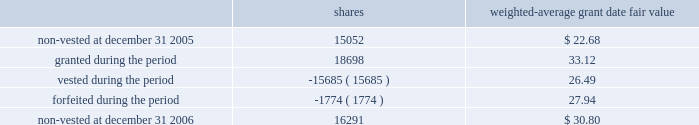O 2019 r e i l l y a u t o m o t i v e 2 0 0 6 a n n u a l r e p o r t p a g e 38 $ 11080000 , in the years ended december 31 , 2006 , 2005 and 2004 , respectively .
The remaining unrecognized compensation cost related to unvested awards at december 31 , 2006 , was $ 7702000 and the weighted-average period of time over which this cost will be recognized is 3.3 years .
Employee stock purchase plan the company 2019s employee stock purchase plan permits all eligible employees to purchase shares of the company 2019s common stock at 85% ( 85 % ) of the fair market value .
Participants may authorize the company to withhold up to 5% ( 5 % ) of their annual salary to participate in the plan .
The stock purchase plan authorizes up to 2600000 shares to be granted .
During the year ended december 31 , 2006 , the company issued 165306 shares under the purchase plan at a weighted average price of $ 27.36 per share .
During the year ended december 31 , 2005 , the company issued 161903 shares under the purchase plan at a weighted average price of $ 27.57 per share .
During the year ended december 31 , 2004 , the company issued 187754 shares under the purchase plan at a weighted average price of $ 20.85 per share .
Sfas no .
123r requires compensation expense to be recognized based on the discount between the grant date fair value and the employee purchase price for shares sold to employees .
During the year ended december 31 , 2006 , the company recorded $ 799000 of compensation cost related to employee share purchases and a corresponding income tax benefit of $ 295000 .
At december 31 , 2006 , approximately 400000 shares were reserved for future issuance .
Other employee benefit plans the company sponsors a contributory profit sharing and savings plan that covers substantially all employees who are at least 21 years of age and have at least six months of service .
The company has agreed to make matching contributions equal to 50% ( 50 % ) of the first 2% ( 2 % ) of each employee 2019s wages that are contributed and 25% ( 25 % ) of the next 4% ( 4 % ) of each employee 2019s wages that are contributed .
The company also makes additional discretionary profit sharing contributions to the plan on an annual basis as determined by the board of directors .
The company 2019s matching and profit sharing contributions under this plan are funded in the form of shares of the company 2019s common stock .
A total of 4200000 shares of common stock have been authorized for issuance under this plan .
During the year ended december 31 , 2006 , the company recorded $ 6429000 of compensation cost for contributions to this plan and a corresponding income tax benefit of $ 2372000 .
During the year ended december 31 , 2005 , the company recorded $ 6606000 of compensation cost for contributions to this plan and a corresponding income tax benefit of $ 2444000 .
During the year ended december 31 , 2004 , the company recorded $ 5278000 of compensation cost for contributions to this plan and a corresponding income tax benefit of $ 1969000 .
The compensation cost recorded in 2006 includes matching contributions made in 2006 and profit sharing contributions accrued in 2006 to be funded with issuance of shares of common stock in 2007 .
The company issued 204000 shares in 2006 to fund profit sharing and matching contributions at an average grant date fair value of $ 34.34 .
The company issued 210461 shares in 2005 to fund profit sharing and matching contributions at an average grant date fair value of $ 25.79 .
The company issued 238828 shares in 2004 to fund profit sharing and matching contributions at an average grant date fair value of $ 19.36 .
A portion of these shares related to profit sharing contributions accrued in prior periods .
At december 31 , 2006 , approximately 1061000 shares were reserved for future issuance under this plan .
The company has in effect a performance incentive plan for the company 2019s senior management under which the company awards shares of restricted stock that vest equally over a three-year period and are held in escrow until such vesting has occurred .
Shares are forfeited when an employee ceases employment .
A total of 800000 shares of common stock have been authorized for issuance under this plan .
Shares awarded under this plan are valued based on the market price of the company 2019s common stock on the date of grant and compensation cost is recorded over the vesting period .
The company recorded $ 416000 of compensation cost for this plan for the year ended december 31 , 2006 and recognized a corresponding income tax benefit of $ 154000 .
The company recorded $ 289000 of compensation cost for this plan for the year ended december 31 , 2005 and recognized a corresponding income tax benefit of $ 107000 .
The company recorded $ 248000 of compensation cost for this plan for the year ended december 31 , 2004 and recognized a corresponding income tax benefit of $ 93000 .
The total fair value of shares vested ( at vest date ) for the years ended december 31 , 2006 , 2005 and 2004 were $ 503000 , $ 524000 and $ 335000 , respectively .
The remaining unrecognized compensation cost related to unvested awards at december 31 , 2006 was $ 536000 .
The company awarded 18698 shares under this plan in 2006 with an average grant date fair value of $ 33.12 .
The company awarded 14986 shares under this plan in 2005 with an average grant date fair value of $ 25.41 .
The company awarded 15834 shares under this plan in 2004 with an average grant date fair value of $ 19.05 .
Compensation cost for shares awarded in 2006 will be recognized over the three-year vesting period .
Changes in the company 2019s restricted stock for the year ended december 31 , 2006 were as follows : weighted- average grant date shares fair value .
At december 31 , 2006 , approximately 659000 shares were reserved for future issuance under this plan .
N o t e s t o c o n s o l i d a t e d f i n a n c i a l s t a t e m e n t s ( cont inued ) .
The non-vested restricted stock balance as if december 31 2006 was what percent of the total shares reserved for future issuance under this plan? 
Computations: (16291 / 659000)
Answer: 0.02472. 